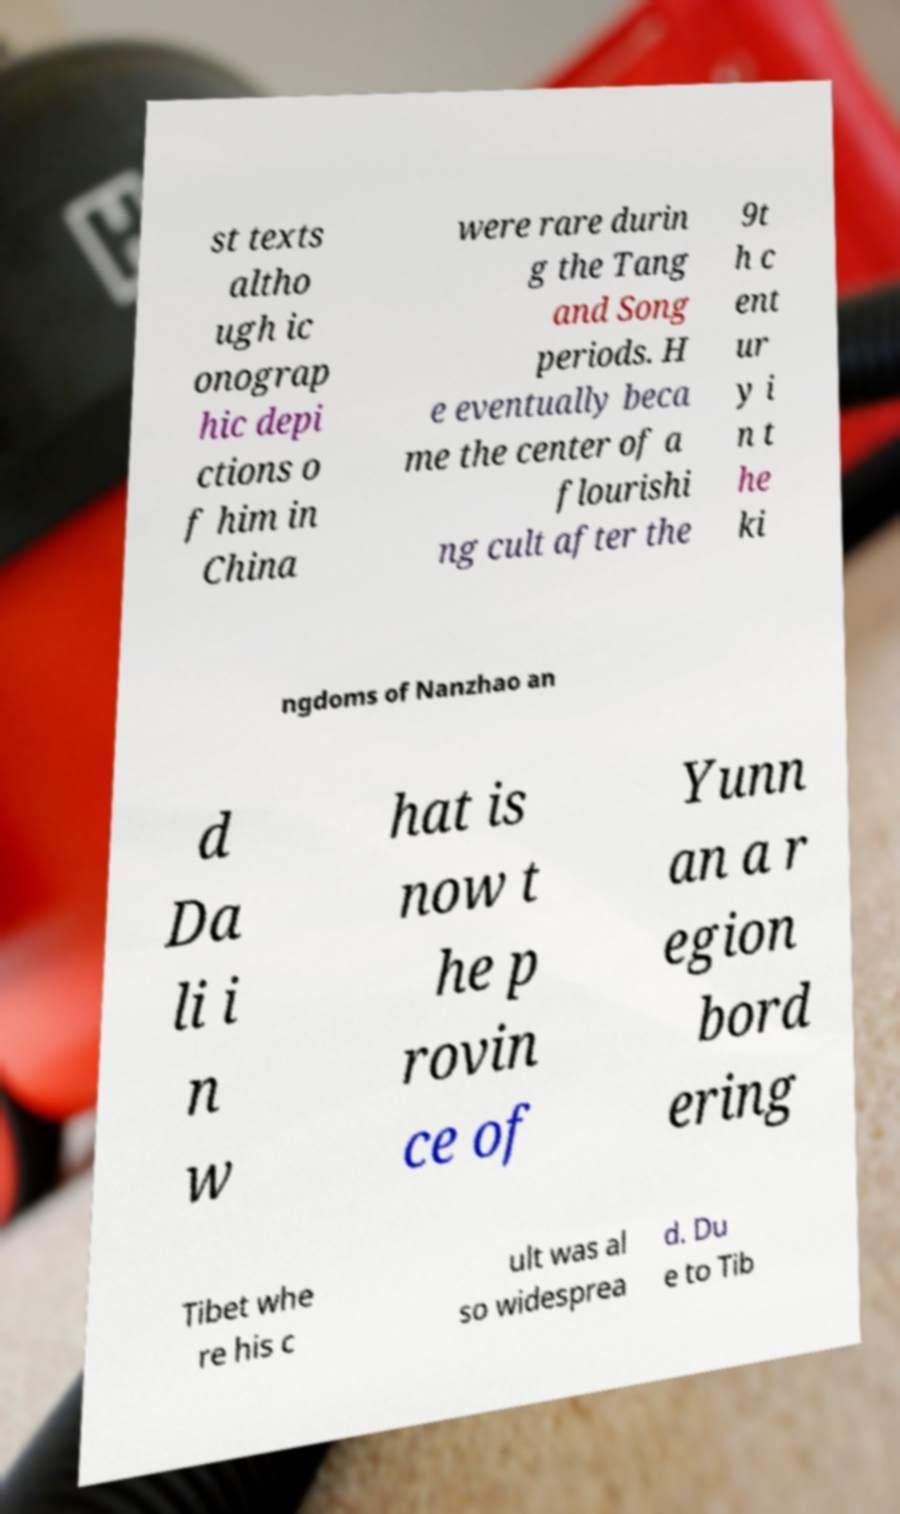There's text embedded in this image that I need extracted. Can you transcribe it verbatim? st texts altho ugh ic onograp hic depi ctions o f him in China were rare durin g the Tang and Song periods. H e eventually beca me the center of a flourishi ng cult after the 9t h c ent ur y i n t he ki ngdoms of Nanzhao an d Da li i n w hat is now t he p rovin ce of Yunn an a r egion bord ering Tibet whe re his c ult was al so widesprea d. Du e to Tib 